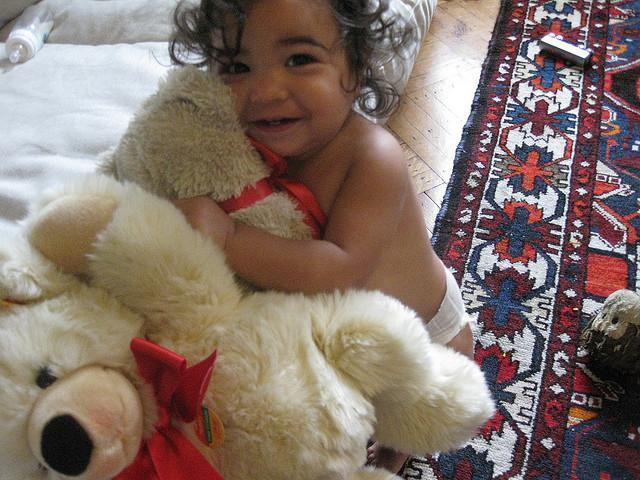How many teddy bears are visible?
Give a very brief answer. 2. 